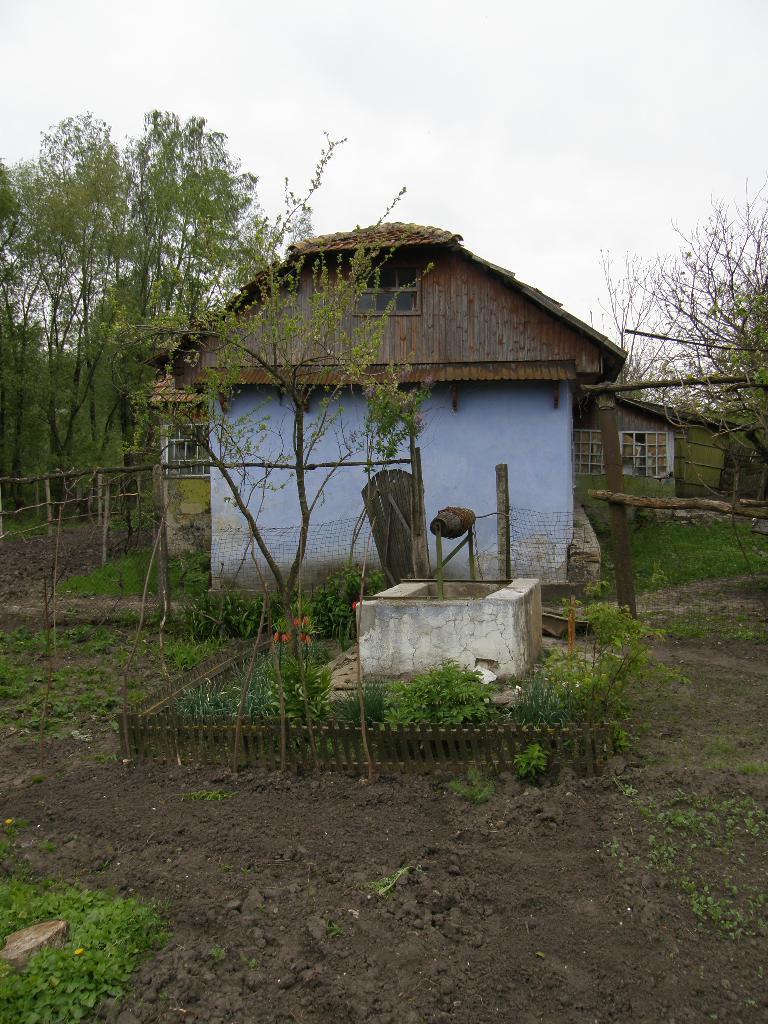Describe this image in one or two sentences. In this image there is a house, in front of the house there is a wooden fence and there is a rock structure like a well, around that there are plants. In the background there are trees and plants. 